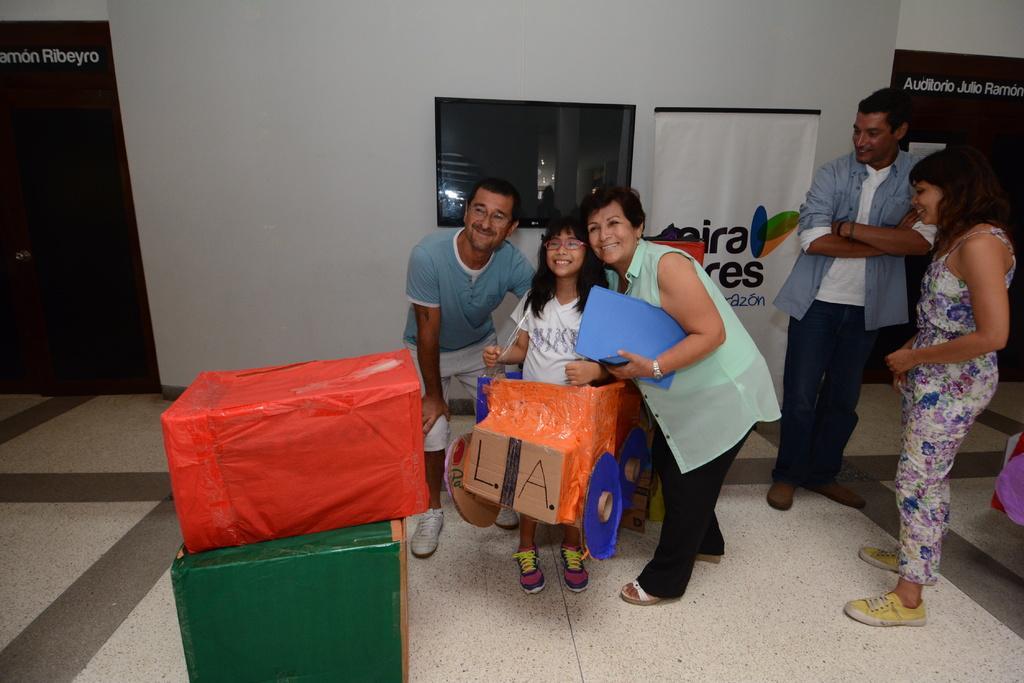Describe this image in one or two sentences. This picture seems to be clicked inside the hall. On the right we can see the two persons standing on the floor. In the center we can see a person holding some objects and standing, we can see a girl wearing white color dress and some other object, smiling and standing. On the left we can see a man wearing t-shirt, smiling and standing and we can see there are some boxes placed on the ground. In the background we can see the wall, text on the banners, window and the door and some other objects. 